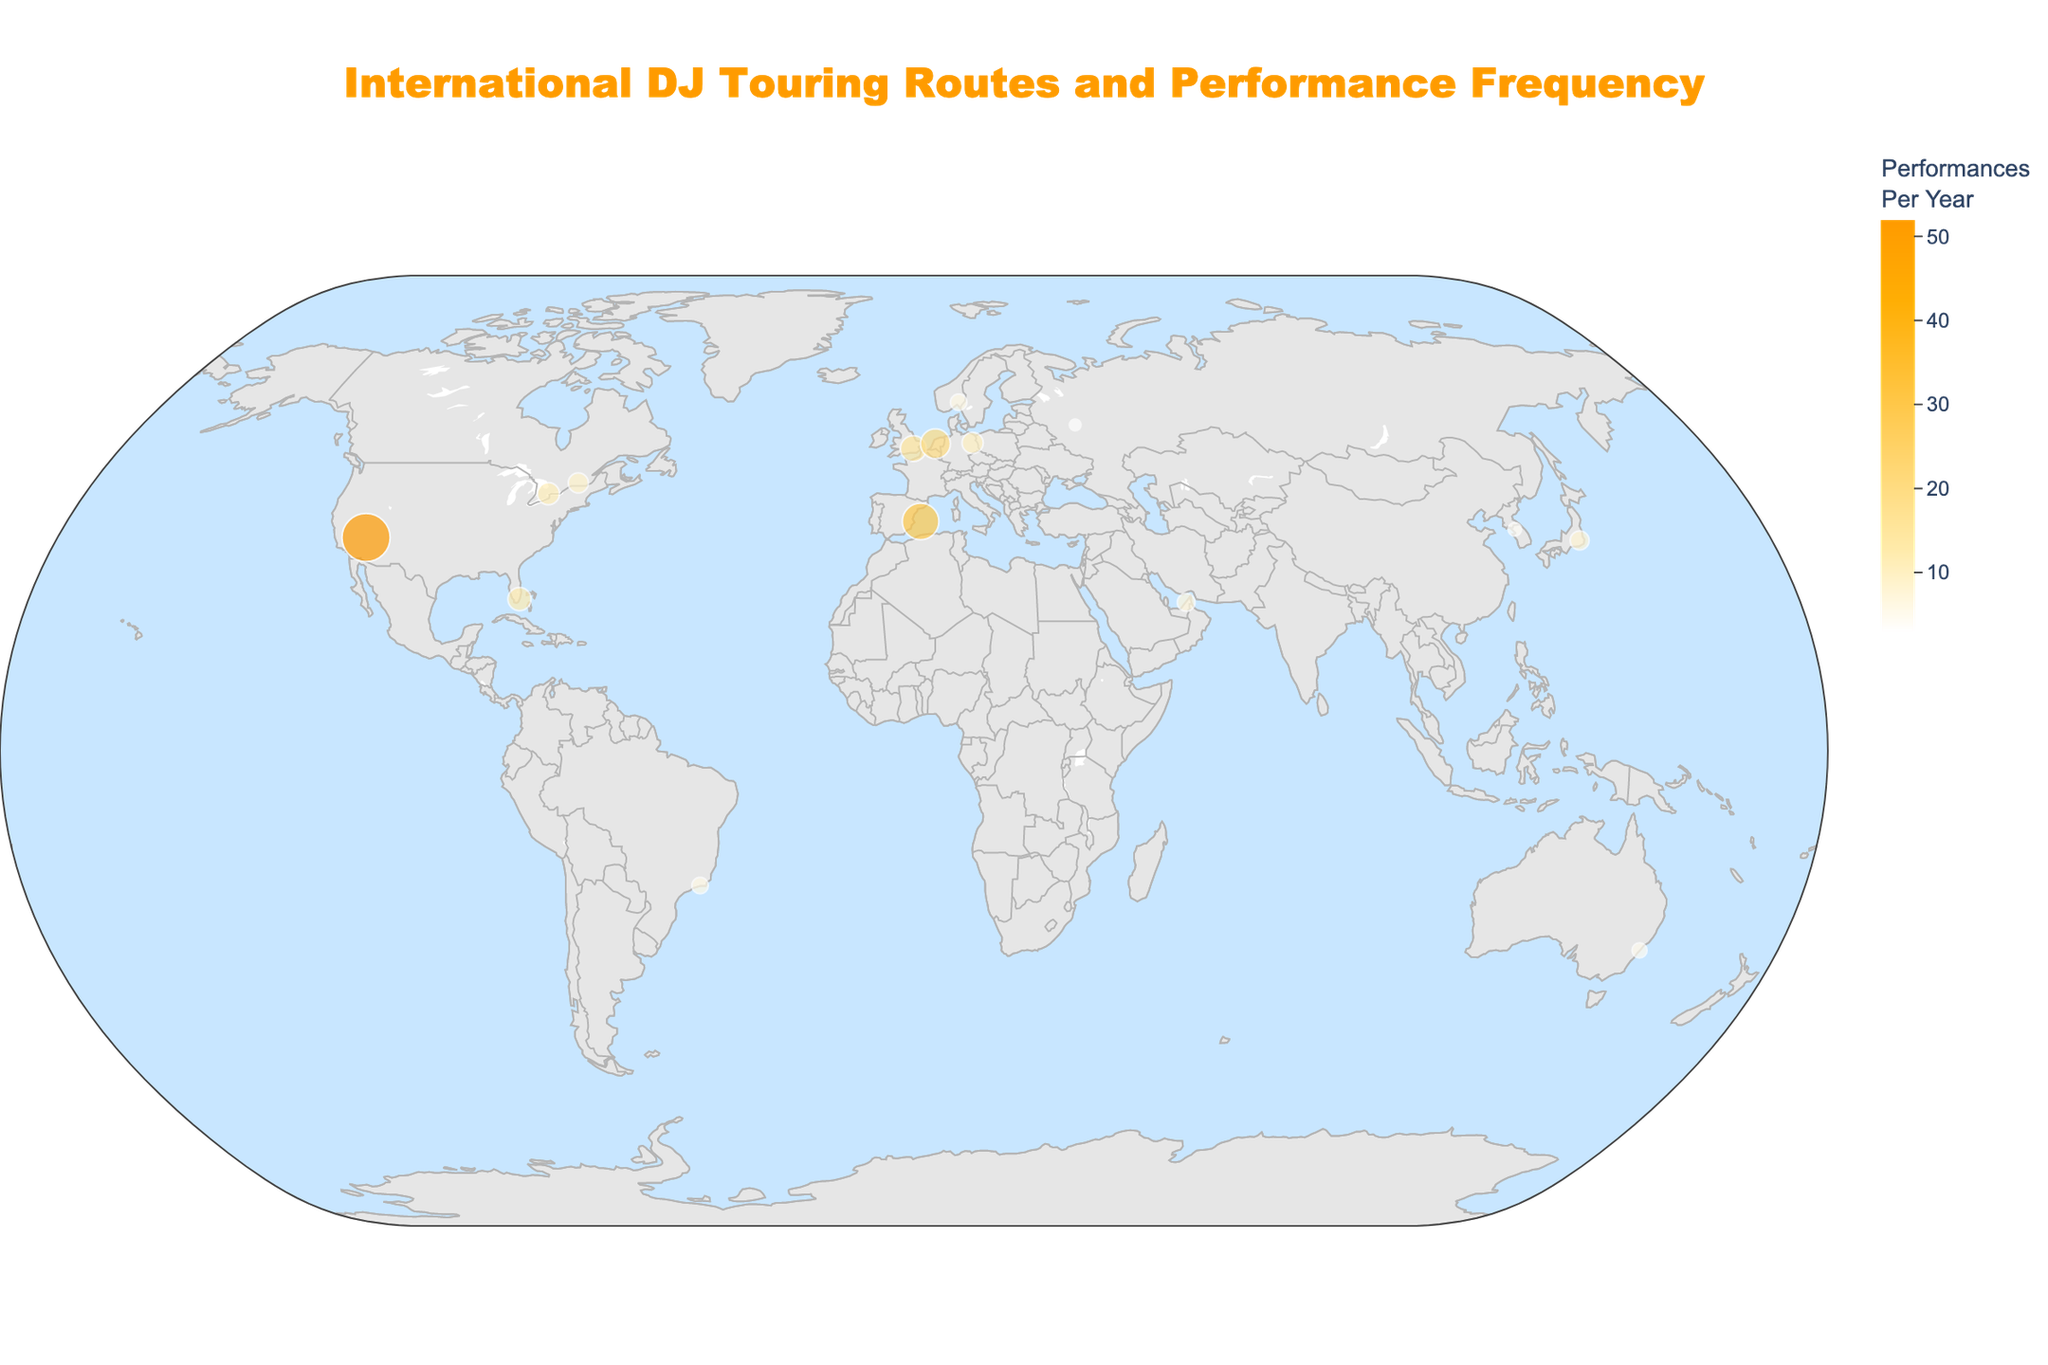Which DJ has the highest number of performances per year, and which city do they play in? The DJ with the largest circle size and highest performance color on the map will indicate the highest performances per year. The DJ Tiësto in Las Vegas stands out.
Answer: Tiësto in Las Vegas How many DJs perform in the USA? Count the locations with their respective DJs in the USA on the map. The cities are Las Vegas, Miami, and Toronto.
Answer: 3 Which DJ has the least performances per year, and where is this city located? The smallest circle on the map with the least intense color indicates the DJ with the least performances. Above & Beyond in Moscow has the smallest circle.
Answer: Above & Beyond in Moscow What is the average number of performances per year by the DJs? Sum up all performances per year and divide by the total number of DJs. 15+52+20+30+12+8+10+6+5+7+9+11+6+4+3=198. There are 15 DJs. 198/15 = 13.2.
Answer: 13.2 Which continent has the highest concentration of DJ performances, and how can you tell? Europe has the highest concentration because it has multiple major cities like London, Amsterdam, Berlin, Ibiza, and Moscow with significant performances.
Answer: Europe Which DJ performs the most in Asia, and in which cities? Look at the dots representing cities in Asia (Tokyo, Seoul). Marshmello in Tokyo has more performances than The Chainsmokers in Seoul.
Answer: Marshmello in Tokyo How many DJs perform in Europe, and which cities are they associated with? Identify the cities in Europe on the map and count the DJs. Cities are London, Amsterdam, Berlin, Ibiza, Oslo, and Moscow. Count the DJs associated: Calvin Harris, Martin Garrix, David Guetta, Skrillex, Kygo, Above & Beyond.
Answer: 6 Compare the number of performances between DJs in Miami and Tokyo. Who performs more? Identify the circles representing Miami and Tokyo and compare the number of performances. Armin van Buuren in Miami has 12, Marshmello in Tokyo has 8.
Answer: Armin van Buuren in Miami How many DJ performances occur in total in Europe? Add up all the performances per year for DJs performing in European cities. Calvin Harris (15), Martin Garrix (20), David Guetta (30), Skrillex (10), Kygo (6), Above & Beyond (3). Sum: 15+20+30+10+6+3=84.
Answer: 84 Is there a correlation between the number of performances and the geographical location (distance from the equator)? Observe if cities closer to the equator (like Rio de Janeiro, Miami) have fewer or more performances as compared to cities farther away (like London, Berlin). There's no clear correlation, as locations far and near to the equator both have varying performances.
Answer: No clear correlation 